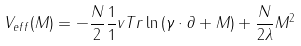Convert formula to latex. <formula><loc_0><loc_0><loc_500><loc_500>V _ { e f f } ( M ) = - \frac { N } { 2 } \frac { 1 } { 1 } { v } T r \ln \left ( \gamma \cdot \partial + M \right ) + \frac { N } { 2 \lambda } M ^ { 2 }</formula> 